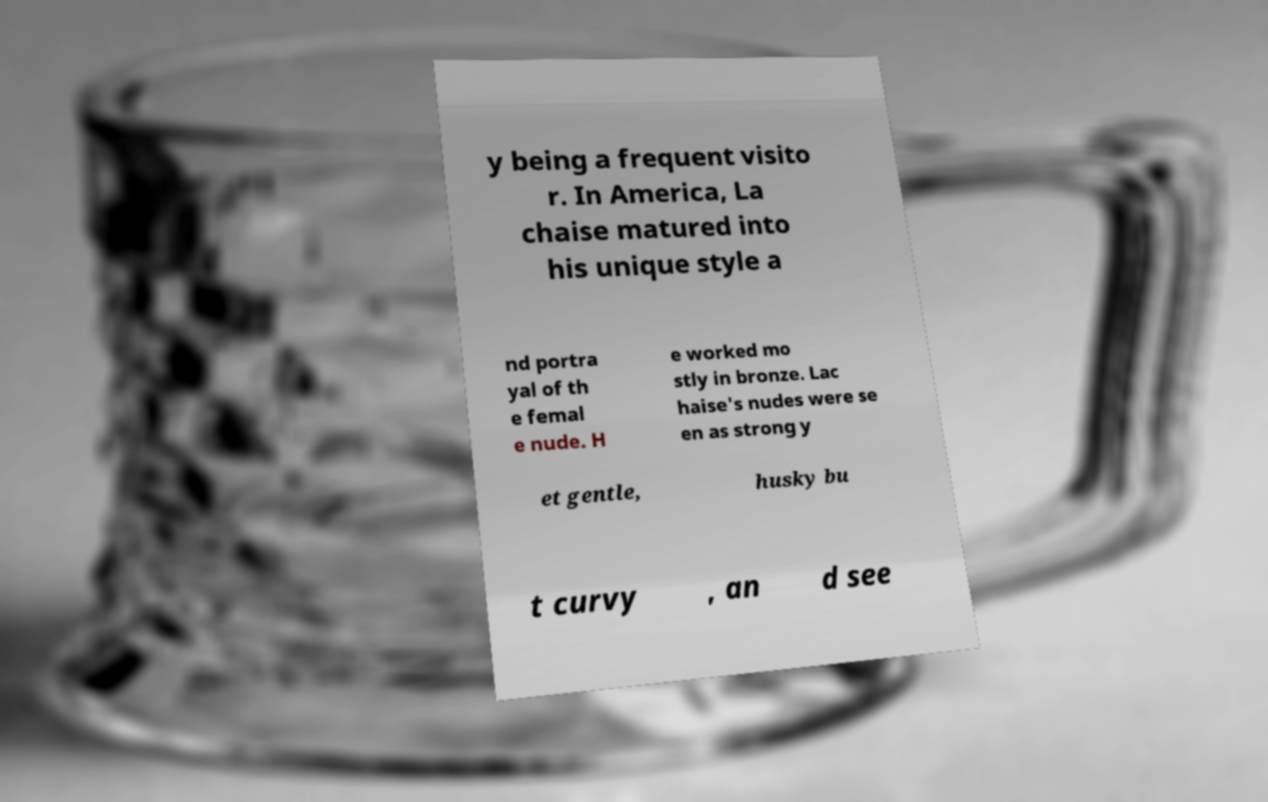There's text embedded in this image that I need extracted. Can you transcribe it verbatim? y being a frequent visito r. In America, La chaise matured into his unique style a nd portra yal of th e femal e nude. H e worked mo stly in bronze. Lac haise's nudes were se en as strong y et gentle, husky bu t curvy , an d see 